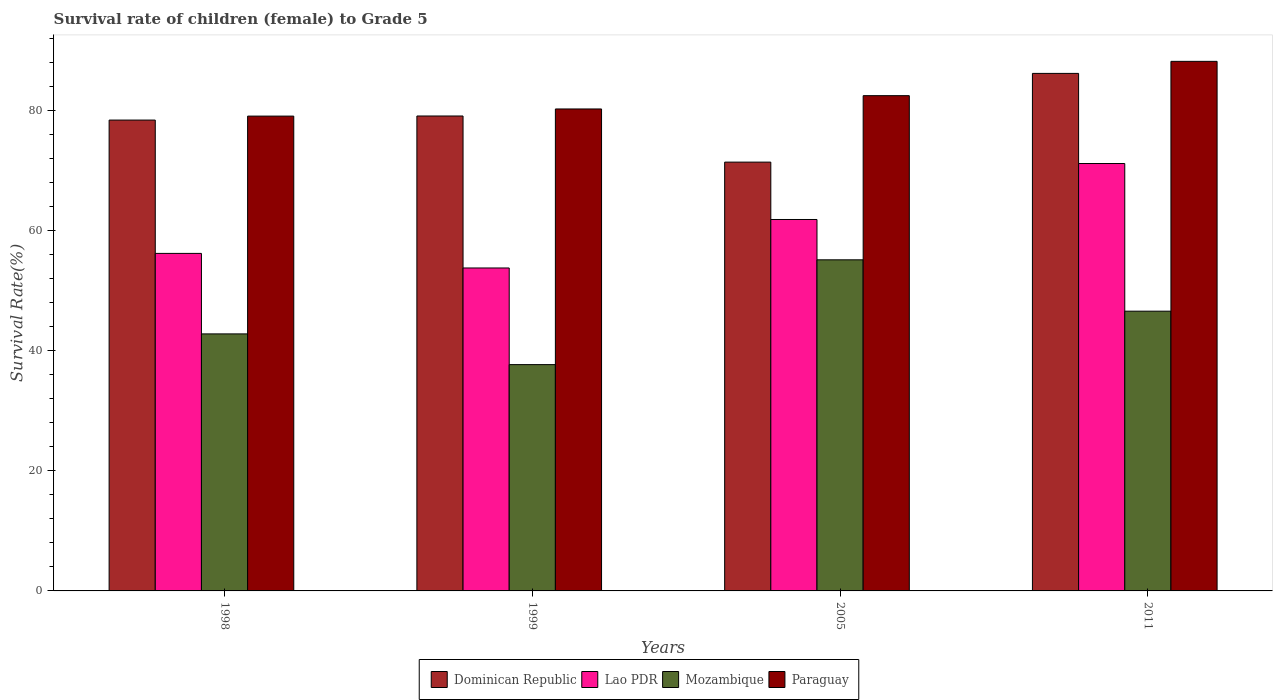How many different coloured bars are there?
Offer a very short reply. 4. How many groups of bars are there?
Ensure brevity in your answer.  4. Are the number of bars per tick equal to the number of legend labels?
Offer a very short reply. Yes. How many bars are there on the 4th tick from the left?
Keep it short and to the point. 4. How many bars are there on the 1st tick from the right?
Provide a succinct answer. 4. In how many cases, is the number of bars for a given year not equal to the number of legend labels?
Your response must be concise. 0. What is the survival rate of female children to grade 5 in Dominican Republic in 2005?
Provide a short and direct response. 71.38. Across all years, what is the maximum survival rate of female children to grade 5 in Mozambique?
Your response must be concise. 55.12. Across all years, what is the minimum survival rate of female children to grade 5 in Lao PDR?
Make the answer very short. 53.76. In which year was the survival rate of female children to grade 5 in Dominican Republic maximum?
Your answer should be very brief. 2011. In which year was the survival rate of female children to grade 5 in Paraguay minimum?
Your answer should be very brief. 1998. What is the total survival rate of female children to grade 5 in Lao PDR in the graph?
Make the answer very short. 242.93. What is the difference between the survival rate of female children to grade 5 in Paraguay in 1998 and that in 2005?
Provide a short and direct response. -3.4. What is the difference between the survival rate of female children to grade 5 in Lao PDR in 2011 and the survival rate of female children to grade 5 in Mozambique in 1998?
Provide a succinct answer. 28.36. What is the average survival rate of female children to grade 5 in Lao PDR per year?
Your answer should be compact. 60.73. In the year 2005, what is the difference between the survival rate of female children to grade 5 in Paraguay and survival rate of female children to grade 5 in Lao PDR?
Make the answer very short. 20.62. In how many years, is the survival rate of female children to grade 5 in Paraguay greater than 44 %?
Offer a terse response. 4. What is the ratio of the survival rate of female children to grade 5 in Paraguay in 1998 to that in 1999?
Keep it short and to the point. 0.99. Is the survival rate of female children to grade 5 in Lao PDR in 2005 less than that in 2011?
Your answer should be compact. Yes. Is the difference between the survival rate of female children to grade 5 in Paraguay in 1999 and 2005 greater than the difference between the survival rate of female children to grade 5 in Lao PDR in 1999 and 2005?
Your answer should be compact. Yes. What is the difference between the highest and the second highest survival rate of female children to grade 5 in Paraguay?
Provide a succinct answer. 5.71. What is the difference between the highest and the lowest survival rate of female children to grade 5 in Dominican Republic?
Your response must be concise. 14.77. In how many years, is the survival rate of female children to grade 5 in Dominican Republic greater than the average survival rate of female children to grade 5 in Dominican Republic taken over all years?
Your answer should be very brief. 2. Is the sum of the survival rate of female children to grade 5 in Lao PDR in 1998 and 1999 greater than the maximum survival rate of female children to grade 5 in Dominican Republic across all years?
Provide a short and direct response. Yes. What does the 4th bar from the left in 1998 represents?
Your answer should be compact. Paraguay. What does the 2nd bar from the right in 1998 represents?
Keep it short and to the point. Mozambique. Is it the case that in every year, the sum of the survival rate of female children to grade 5 in Paraguay and survival rate of female children to grade 5 in Mozambique is greater than the survival rate of female children to grade 5 in Dominican Republic?
Make the answer very short. Yes. How many years are there in the graph?
Provide a succinct answer. 4. What is the difference between two consecutive major ticks on the Y-axis?
Your answer should be very brief. 20. Does the graph contain grids?
Keep it short and to the point. No. Where does the legend appear in the graph?
Provide a short and direct response. Bottom center. How many legend labels are there?
Give a very brief answer. 4. What is the title of the graph?
Your answer should be very brief. Survival rate of children (female) to Grade 5. Does "San Marino" appear as one of the legend labels in the graph?
Provide a short and direct response. No. What is the label or title of the Y-axis?
Offer a terse response. Survival Rate(%). What is the Survival Rate(%) of Dominican Republic in 1998?
Keep it short and to the point. 78.38. What is the Survival Rate(%) of Lao PDR in 1998?
Make the answer very short. 56.19. What is the Survival Rate(%) of Mozambique in 1998?
Give a very brief answer. 42.79. What is the Survival Rate(%) of Paraguay in 1998?
Offer a terse response. 79.04. What is the Survival Rate(%) in Dominican Republic in 1999?
Keep it short and to the point. 79.06. What is the Survival Rate(%) of Lao PDR in 1999?
Your response must be concise. 53.76. What is the Survival Rate(%) in Mozambique in 1999?
Offer a terse response. 37.67. What is the Survival Rate(%) in Paraguay in 1999?
Offer a terse response. 80.23. What is the Survival Rate(%) of Dominican Republic in 2005?
Give a very brief answer. 71.38. What is the Survival Rate(%) of Lao PDR in 2005?
Provide a short and direct response. 61.83. What is the Survival Rate(%) in Mozambique in 2005?
Ensure brevity in your answer.  55.12. What is the Survival Rate(%) in Paraguay in 2005?
Your response must be concise. 82.45. What is the Survival Rate(%) in Dominican Republic in 2011?
Provide a short and direct response. 86.15. What is the Survival Rate(%) in Lao PDR in 2011?
Keep it short and to the point. 71.15. What is the Survival Rate(%) of Mozambique in 2011?
Offer a very short reply. 46.57. What is the Survival Rate(%) of Paraguay in 2011?
Give a very brief answer. 88.16. Across all years, what is the maximum Survival Rate(%) of Dominican Republic?
Your answer should be very brief. 86.15. Across all years, what is the maximum Survival Rate(%) of Lao PDR?
Ensure brevity in your answer.  71.15. Across all years, what is the maximum Survival Rate(%) in Mozambique?
Keep it short and to the point. 55.12. Across all years, what is the maximum Survival Rate(%) of Paraguay?
Your response must be concise. 88.16. Across all years, what is the minimum Survival Rate(%) in Dominican Republic?
Make the answer very short. 71.38. Across all years, what is the minimum Survival Rate(%) in Lao PDR?
Your response must be concise. 53.76. Across all years, what is the minimum Survival Rate(%) of Mozambique?
Ensure brevity in your answer.  37.67. Across all years, what is the minimum Survival Rate(%) of Paraguay?
Ensure brevity in your answer.  79.04. What is the total Survival Rate(%) of Dominican Republic in the graph?
Your answer should be very brief. 314.98. What is the total Survival Rate(%) of Lao PDR in the graph?
Make the answer very short. 242.93. What is the total Survival Rate(%) of Mozambique in the graph?
Your answer should be very brief. 182.15. What is the total Survival Rate(%) in Paraguay in the graph?
Your answer should be very brief. 329.88. What is the difference between the Survival Rate(%) in Dominican Republic in 1998 and that in 1999?
Ensure brevity in your answer.  -0.68. What is the difference between the Survival Rate(%) in Lao PDR in 1998 and that in 1999?
Offer a terse response. 2.43. What is the difference between the Survival Rate(%) in Mozambique in 1998 and that in 1999?
Make the answer very short. 5.11. What is the difference between the Survival Rate(%) in Paraguay in 1998 and that in 1999?
Offer a terse response. -1.19. What is the difference between the Survival Rate(%) in Dominican Republic in 1998 and that in 2005?
Offer a very short reply. 7. What is the difference between the Survival Rate(%) of Lao PDR in 1998 and that in 2005?
Keep it short and to the point. -5.64. What is the difference between the Survival Rate(%) of Mozambique in 1998 and that in 2005?
Your response must be concise. -12.33. What is the difference between the Survival Rate(%) in Paraguay in 1998 and that in 2005?
Provide a succinct answer. -3.4. What is the difference between the Survival Rate(%) in Dominican Republic in 1998 and that in 2011?
Offer a very short reply. -7.77. What is the difference between the Survival Rate(%) of Lao PDR in 1998 and that in 2011?
Ensure brevity in your answer.  -14.96. What is the difference between the Survival Rate(%) of Mozambique in 1998 and that in 2011?
Ensure brevity in your answer.  -3.78. What is the difference between the Survival Rate(%) in Paraguay in 1998 and that in 2011?
Offer a very short reply. -9.11. What is the difference between the Survival Rate(%) in Dominican Republic in 1999 and that in 2005?
Your response must be concise. 7.68. What is the difference between the Survival Rate(%) in Lao PDR in 1999 and that in 2005?
Make the answer very short. -8.07. What is the difference between the Survival Rate(%) in Mozambique in 1999 and that in 2005?
Provide a short and direct response. -17.45. What is the difference between the Survival Rate(%) in Paraguay in 1999 and that in 2005?
Your answer should be compact. -2.22. What is the difference between the Survival Rate(%) in Dominican Republic in 1999 and that in 2011?
Make the answer very short. -7.09. What is the difference between the Survival Rate(%) in Lao PDR in 1999 and that in 2011?
Your answer should be very brief. -17.39. What is the difference between the Survival Rate(%) in Mozambique in 1999 and that in 2011?
Your answer should be compact. -8.9. What is the difference between the Survival Rate(%) in Paraguay in 1999 and that in 2011?
Make the answer very short. -7.93. What is the difference between the Survival Rate(%) in Dominican Republic in 2005 and that in 2011?
Make the answer very short. -14.77. What is the difference between the Survival Rate(%) in Lao PDR in 2005 and that in 2011?
Provide a short and direct response. -9.32. What is the difference between the Survival Rate(%) in Mozambique in 2005 and that in 2011?
Ensure brevity in your answer.  8.55. What is the difference between the Survival Rate(%) of Paraguay in 2005 and that in 2011?
Offer a terse response. -5.71. What is the difference between the Survival Rate(%) in Dominican Republic in 1998 and the Survival Rate(%) in Lao PDR in 1999?
Your answer should be compact. 24.62. What is the difference between the Survival Rate(%) of Dominican Republic in 1998 and the Survival Rate(%) of Mozambique in 1999?
Provide a succinct answer. 40.71. What is the difference between the Survival Rate(%) of Dominican Republic in 1998 and the Survival Rate(%) of Paraguay in 1999?
Ensure brevity in your answer.  -1.85. What is the difference between the Survival Rate(%) of Lao PDR in 1998 and the Survival Rate(%) of Mozambique in 1999?
Your answer should be very brief. 18.51. What is the difference between the Survival Rate(%) in Lao PDR in 1998 and the Survival Rate(%) in Paraguay in 1999?
Provide a succinct answer. -24.04. What is the difference between the Survival Rate(%) of Mozambique in 1998 and the Survival Rate(%) of Paraguay in 1999?
Your answer should be compact. -37.44. What is the difference between the Survival Rate(%) of Dominican Republic in 1998 and the Survival Rate(%) of Lao PDR in 2005?
Provide a short and direct response. 16.55. What is the difference between the Survival Rate(%) of Dominican Republic in 1998 and the Survival Rate(%) of Mozambique in 2005?
Give a very brief answer. 23.26. What is the difference between the Survival Rate(%) in Dominican Republic in 1998 and the Survival Rate(%) in Paraguay in 2005?
Keep it short and to the point. -4.06. What is the difference between the Survival Rate(%) of Lao PDR in 1998 and the Survival Rate(%) of Mozambique in 2005?
Give a very brief answer. 1.07. What is the difference between the Survival Rate(%) of Lao PDR in 1998 and the Survival Rate(%) of Paraguay in 2005?
Provide a succinct answer. -26.26. What is the difference between the Survival Rate(%) of Mozambique in 1998 and the Survival Rate(%) of Paraguay in 2005?
Make the answer very short. -39.66. What is the difference between the Survival Rate(%) of Dominican Republic in 1998 and the Survival Rate(%) of Lao PDR in 2011?
Your answer should be very brief. 7.23. What is the difference between the Survival Rate(%) of Dominican Republic in 1998 and the Survival Rate(%) of Mozambique in 2011?
Provide a succinct answer. 31.81. What is the difference between the Survival Rate(%) of Dominican Republic in 1998 and the Survival Rate(%) of Paraguay in 2011?
Your answer should be very brief. -9.77. What is the difference between the Survival Rate(%) of Lao PDR in 1998 and the Survival Rate(%) of Mozambique in 2011?
Keep it short and to the point. 9.62. What is the difference between the Survival Rate(%) of Lao PDR in 1998 and the Survival Rate(%) of Paraguay in 2011?
Make the answer very short. -31.97. What is the difference between the Survival Rate(%) in Mozambique in 1998 and the Survival Rate(%) in Paraguay in 2011?
Offer a very short reply. -45.37. What is the difference between the Survival Rate(%) of Dominican Republic in 1999 and the Survival Rate(%) of Lao PDR in 2005?
Make the answer very short. 17.23. What is the difference between the Survival Rate(%) of Dominican Republic in 1999 and the Survival Rate(%) of Mozambique in 2005?
Provide a short and direct response. 23.94. What is the difference between the Survival Rate(%) in Dominican Republic in 1999 and the Survival Rate(%) in Paraguay in 2005?
Your response must be concise. -3.38. What is the difference between the Survival Rate(%) of Lao PDR in 1999 and the Survival Rate(%) of Mozambique in 2005?
Provide a succinct answer. -1.36. What is the difference between the Survival Rate(%) of Lao PDR in 1999 and the Survival Rate(%) of Paraguay in 2005?
Your answer should be compact. -28.69. What is the difference between the Survival Rate(%) in Mozambique in 1999 and the Survival Rate(%) in Paraguay in 2005?
Offer a very short reply. -44.77. What is the difference between the Survival Rate(%) of Dominican Republic in 1999 and the Survival Rate(%) of Lao PDR in 2011?
Offer a terse response. 7.91. What is the difference between the Survival Rate(%) of Dominican Republic in 1999 and the Survival Rate(%) of Mozambique in 2011?
Your answer should be compact. 32.49. What is the difference between the Survival Rate(%) of Dominican Republic in 1999 and the Survival Rate(%) of Paraguay in 2011?
Provide a succinct answer. -9.1. What is the difference between the Survival Rate(%) in Lao PDR in 1999 and the Survival Rate(%) in Mozambique in 2011?
Ensure brevity in your answer.  7.19. What is the difference between the Survival Rate(%) of Lao PDR in 1999 and the Survival Rate(%) of Paraguay in 2011?
Offer a terse response. -34.4. What is the difference between the Survival Rate(%) of Mozambique in 1999 and the Survival Rate(%) of Paraguay in 2011?
Give a very brief answer. -50.48. What is the difference between the Survival Rate(%) in Dominican Republic in 2005 and the Survival Rate(%) in Lao PDR in 2011?
Ensure brevity in your answer.  0.24. What is the difference between the Survival Rate(%) of Dominican Republic in 2005 and the Survival Rate(%) of Mozambique in 2011?
Provide a succinct answer. 24.82. What is the difference between the Survival Rate(%) of Dominican Republic in 2005 and the Survival Rate(%) of Paraguay in 2011?
Your answer should be very brief. -16.77. What is the difference between the Survival Rate(%) in Lao PDR in 2005 and the Survival Rate(%) in Mozambique in 2011?
Your response must be concise. 15.26. What is the difference between the Survival Rate(%) in Lao PDR in 2005 and the Survival Rate(%) in Paraguay in 2011?
Give a very brief answer. -26.33. What is the difference between the Survival Rate(%) in Mozambique in 2005 and the Survival Rate(%) in Paraguay in 2011?
Ensure brevity in your answer.  -33.04. What is the average Survival Rate(%) in Dominican Republic per year?
Keep it short and to the point. 78.74. What is the average Survival Rate(%) of Lao PDR per year?
Offer a terse response. 60.73. What is the average Survival Rate(%) in Mozambique per year?
Give a very brief answer. 45.54. What is the average Survival Rate(%) in Paraguay per year?
Provide a short and direct response. 82.47. In the year 1998, what is the difference between the Survival Rate(%) of Dominican Republic and Survival Rate(%) of Lao PDR?
Offer a very short reply. 22.19. In the year 1998, what is the difference between the Survival Rate(%) in Dominican Republic and Survival Rate(%) in Mozambique?
Your response must be concise. 35.6. In the year 1998, what is the difference between the Survival Rate(%) of Dominican Republic and Survival Rate(%) of Paraguay?
Provide a short and direct response. -0.66. In the year 1998, what is the difference between the Survival Rate(%) in Lao PDR and Survival Rate(%) in Mozambique?
Give a very brief answer. 13.4. In the year 1998, what is the difference between the Survival Rate(%) in Lao PDR and Survival Rate(%) in Paraguay?
Ensure brevity in your answer.  -22.85. In the year 1998, what is the difference between the Survival Rate(%) in Mozambique and Survival Rate(%) in Paraguay?
Your answer should be very brief. -36.26. In the year 1999, what is the difference between the Survival Rate(%) of Dominican Republic and Survival Rate(%) of Lao PDR?
Your answer should be very brief. 25.3. In the year 1999, what is the difference between the Survival Rate(%) in Dominican Republic and Survival Rate(%) in Mozambique?
Offer a terse response. 41.39. In the year 1999, what is the difference between the Survival Rate(%) in Dominican Republic and Survival Rate(%) in Paraguay?
Your answer should be very brief. -1.17. In the year 1999, what is the difference between the Survival Rate(%) of Lao PDR and Survival Rate(%) of Mozambique?
Make the answer very short. 16.09. In the year 1999, what is the difference between the Survival Rate(%) of Lao PDR and Survival Rate(%) of Paraguay?
Provide a succinct answer. -26.47. In the year 1999, what is the difference between the Survival Rate(%) in Mozambique and Survival Rate(%) in Paraguay?
Ensure brevity in your answer.  -42.56. In the year 2005, what is the difference between the Survival Rate(%) of Dominican Republic and Survival Rate(%) of Lao PDR?
Make the answer very short. 9.55. In the year 2005, what is the difference between the Survival Rate(%) in Dominican Republic and Survival Rate(%) in Mozambique?
Your answer should be very brief. 16.26. In the year 2005, what is the difference between the Survival Rate(%) of Dominican Republic and Survival Rate(%) of Paraguay?
Your response must be concise. -11.06. In the year 2005, what is the difference between the Survival Rate(%) of Lao PDR and Survival Rate(%) of Mozambique?
Keep it short and to the point. 6.71. In the year 2005, what is the difference between the Survival Rate(%) in Lao PDR and Survival Rate(%) in Paraguay?
Your answer should be compact. -20.62. In the year 2005, what is the difference between the Survival Rate(%) in Mozambique and Survival Rate(%) in Paraguay?
Your response must be concise. -27.33. In the year 2011, what is the difference between the Survival Rate(%) of Dominican Republic and Survival Rate(%) of Lao PDR?
Provide a short and direct response. 15. In the year 2011, what is the difference between the Survival Rate(%) of Dominican Republic and Survival Rate(%) of Mozambique?
Keep it short and to the point. 39.58. In the year 2011, what is the difference between the Survival Rate(%) in Dominican Republic and Survival Rate(%) in Paraguay?
Your answer should be compact. -2.01. In the year 2011, what is the difference between the Survival Rate(%) of Lao PDR and Survival Rate(%) of Mozambique?
Make the answer very short. 24.58. In the year 2011, what is the difference between the Survival Rate(%) of Lao PDR and Survival Rate(%) of Paraguay?
Provide a short and direct response. -17.01. In the year 2011, what is the difference between the Survival Rate(%) of Mozambique and Survival Rate(%) of Paraguay?
Keep it short and to the point. -41.59. What is the ratio of the Survival Rate(%) in Lao PDR in 1998 to that in 1999?
Your response must be concise. 1.05. What is the ratio of the Survival Rate(%) in Mozambique in 1998 to that in 1999?
Your answer should be compact. 1.14. What is the ratio of the Survival Rate(%) of Paraguay in 1998 to that in 1999?
Ensure brevity in your answer.  0.99. What is the ratio of the Survival Rate(%) in Dominican Republic in 1998 to that in 2005?
Provide a succinct answer. 1.1. What is the ratio of the Survival Rate(%) in Lao PDR in 1998 to that in 2005?
Offer a very short reply. 0.91. What is the ratio of the Survival Rate(%) in Mozambique in 1998 to that in 2005?
Ensure brevity in your answer.  0.78. What is the ratio of the Survival Rate(%) of Paraguay in 1998 to that in 2005?
Keep it short and to the point. 0.96. What is the ratio of the Survival Rate(%) in Dominican Republic in 1998 to that in 2011?
Your response must be concise. 0.91. What is the ratio of the Survival Rate(%) of Lao PDR in 1998 to that in 2011?
Make the answer very short. 0.79. What is the ratio of the Survival Rate(%) in Mozambique in 1998 to that in 2011?
Your response must be concise. 0.92. What is the ratio of the Survival Rate(%) in Paraguay in 1998 to that in 2011?
Ensure brevity in your answer.  0.9. What is the ratio of the Survival Rate(%) of Dominican Republic in 1999 to that in 2005?
Ensure brevity in your answer.  1.11. What is the ratio of the Survival Rate(%) of Lao PDR in 1999 to that in 2005?
Make the answer very short. 0.87. What is the ratio of the Survival Rate(%) in Mozambique in 1999 to that in 2005?
Ensure brevity in your answer.  0.68. What is the ratio of the Survival Rate(%) in Paraguay in 1999 to that in 2005?
Give a very brief answer. 0.97. What is the ratio of the Survival Rate(%) of Dominican Republic in 1999 to that in 2011?
Keep it short and to the point. 0.92. What is the ratio of the Survival Rate(%) in Lao PDR in 1999 to that in 2011?
Offer a terse response. 0.76. What is the ratio of the Survival Rate(%) of Mozambique in 1999 to that in 2011?
Ensure brevity in your answer.  0.81. What is the ratio of the Survival Rate(%) in Paraguay in 1999 to that in 2011?
Your answer should be compact. 0.91. What is the ratio of the Survival Rate(%) in Dominican Republic in 2005 to that in 2011?
Your answer should be very brief. 0.83. What is the ratio of the Survival Rate(%) of Lao PDR in 2005 to that in 2011?
Your response must be concise. 0.87. What is the ratio of the Survival Rate(%) in Mozambique in 2005 to that in 2011?
Give a very brief answer. 1.18. What is the ratio of the Survival Rate(%) in Paraguay in 2005 to that in 2011?
Keep it short and to the point. 0.94. What is the difference between the highest and the second highest Survival Rate(%) of Dominican Republic?
Offer a terse response. 7.09. What is the difference between the highest and the second highest Survival Rate(%) of Lao PDR?
Your answer should be very brief. 9.32. What is the difference between the highest and the second highest Survival Rate(%) in Mozambique?
Make the answer very short. 8.55. What is the difference between the highest and the second highest Survival Rate(%) of Paraguay?
Your answer should be compact. 5.71. What is the difference between the highest and the lowest Survival Rate(%) in Dominican Republic?
Your response must be concise. 14.77. What is the difference between the highest and the lowest Survival Rate(%) of Lao PDR?
Provide a short and direct response. 17.39. What is the difference between the highest and the lowest Survival Rate(%) in Mozambique?
Make the answer very short. 17.45. What is the difference between the highest and the lowest Survival Rate(%) of Paraguay?
Provide a short and direct response. 9.11. 